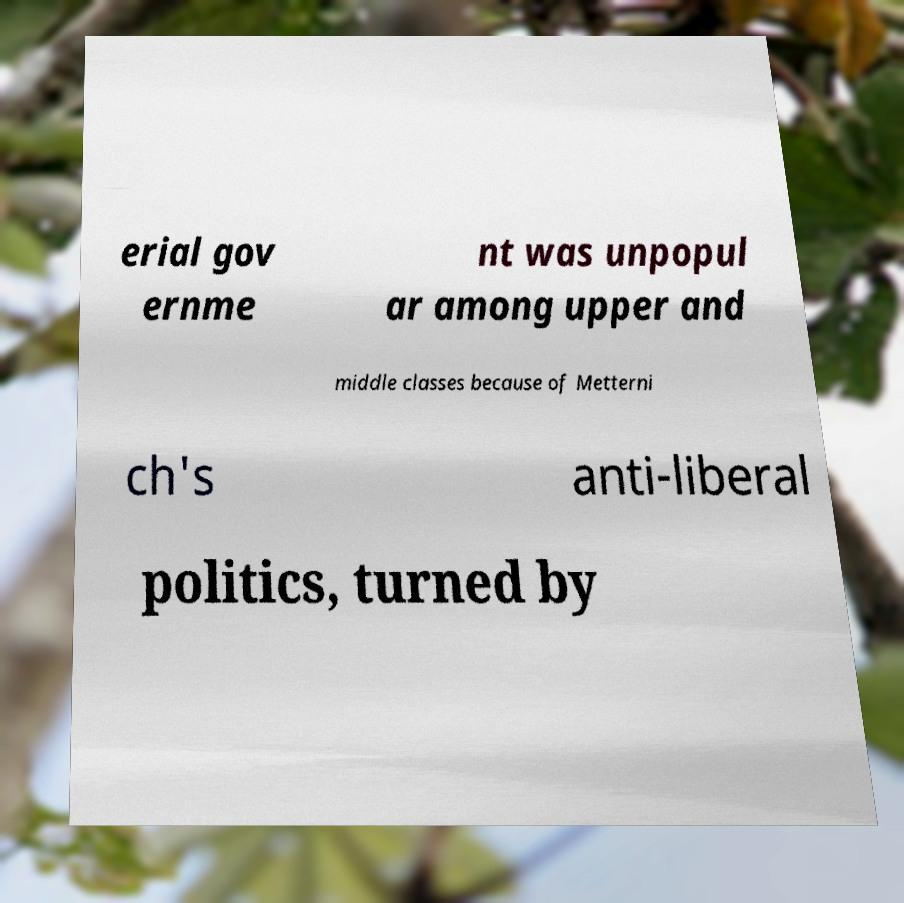Can you accurately transcribe the text from the provided image for me? erial gov ernme nt was unpopul ar among upper and middle classes because of Metterni ch's anti-liberal politics, turned by 